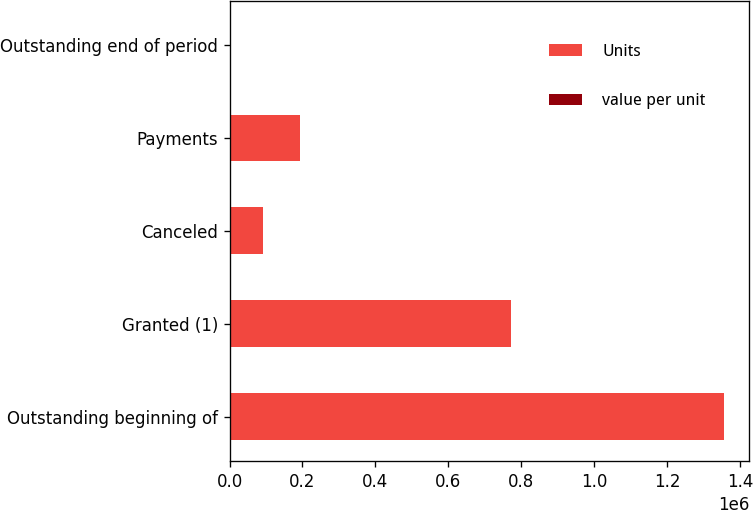Convert chart. <chart><loc_0><loc_0><loc_500><loc_500><stacked_bar_chart><ecel><fcel>Outstanding beginning of<fcel>Granted (1)<fcel>Canceled<fcel>Payments<fcel>Outstanding end of period<nl><fcel>Units<fcel>1.35726e+06<fcel>772653<fcel>91597<fcel>193753<fcel>45.45<nl><fcel>value per unit<fcel>45.45<fcel>27.03<fcel>42.26<fcel>42.26<fcel>38.22<nl></chart> 